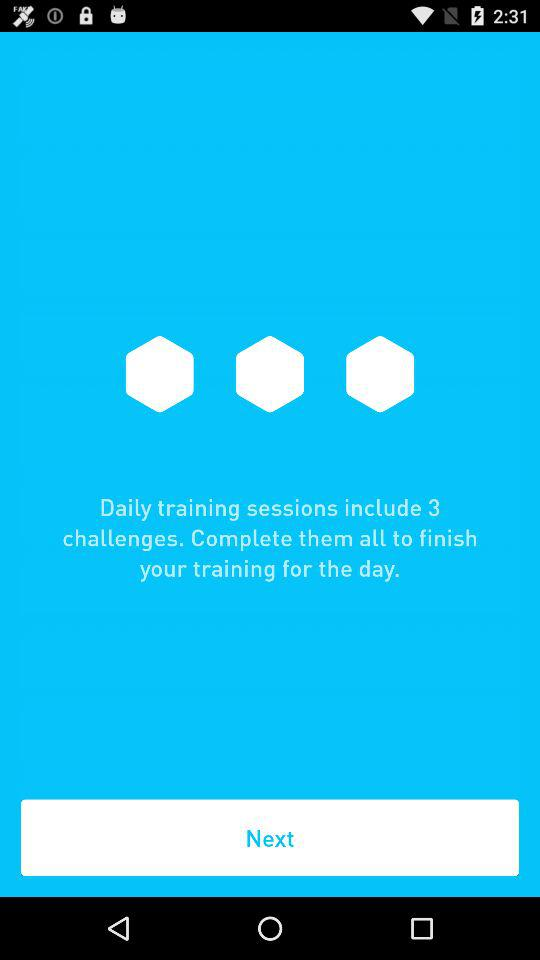How many challenges are there in the daily training sessions? There are 3 challenges. 